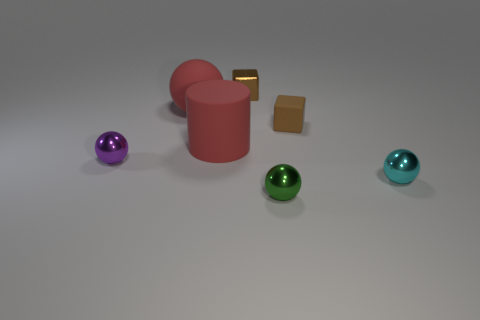Subtract all purple shiny balls. How many balls are left? 3 Subtract 1 blocks. How many blocks are left? 1 Add 3 brown metal objects. How many objects exist? 10 Subtract all red spheres. How many spheres are left? 3 Add 4 red blocks. How many red blocks exist? 4 Subtract 0 yellow cylinders. How many objects are left? 7 Subtract all cubes. How many objects are left? 5 Subtract all purple spheres. Subtract all blue blocks. How many spheres are left? 3 Subtract all blue things. Subtract all brown metallic blocks. How many objects are left? 6 Add 5 large things. How many large things are left? 7 